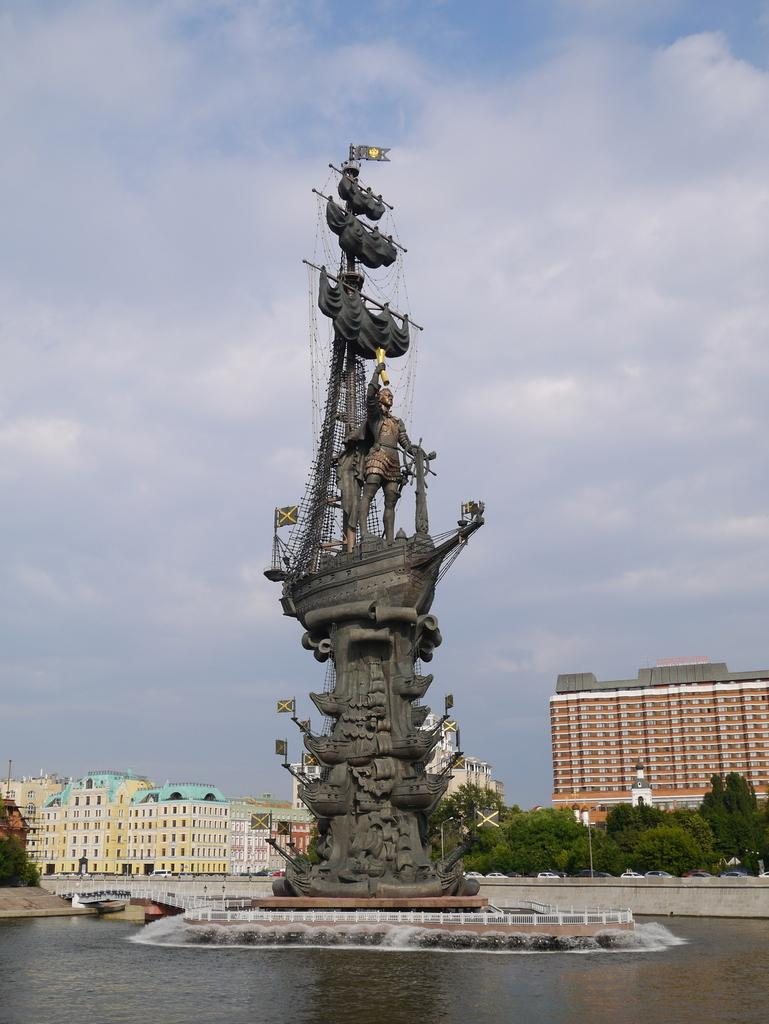What is the main subject of the image? There is a statue in the image. What can be seen in the background of the image? There is water, buildings, trees, and a bridge visible in the image. What is the condition of the sky in the image? Clouds are visible in the sky. What type of society can be seen interacting with the gold in the image? There is no society or gold present in the image. 